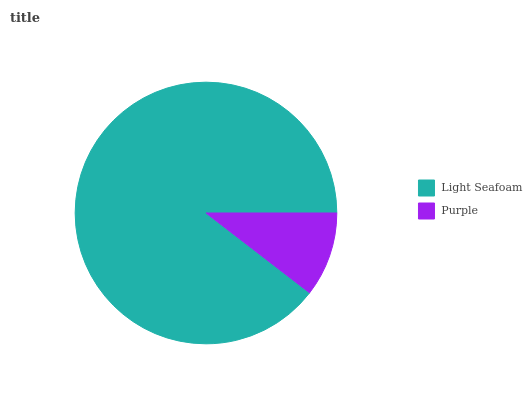Is Purple the minimum?
Answer yes or no. Yes. Is Light Seafoam the maximum?
Answer yes or no. Yes. Is Purple the maximum?
Answer yes or no. No. Is Light Seafoam greater than Purple?
Answer yes or no. Yes. Is Purple less than Light Seafoam?
Answer yes or no. Yes. Is Purple greater than Light Seafoam?
Answer yes or no. No. Is Light Seafoam less than Purple?
Answer yes or no. No. Is Light Seafoam the high median?
Answer yes or no. Yes. Is Purple the low median?
Answer yes or no. Yes. Is Purple the high median?
Answer yes or no. No. Is Light Seafoam the low median?
Answer yes or no. No. 